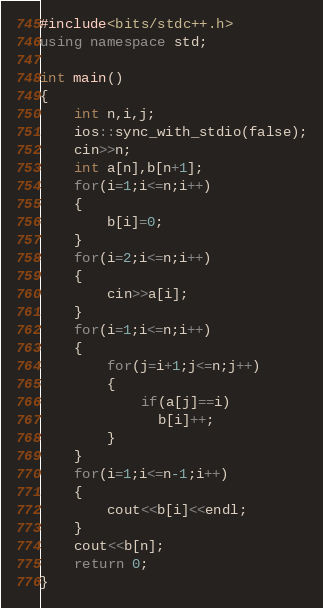<code> <loc_0><loc_0><loc_500><loc_500><_C++_>#include<bits/stdc++.h>
using namespace std;

int main()
{
	int n,i,j;
	ios::sync_with_stdio(false);
	cin>>n;
	int a[n],b[n+1];
	for(i=1;i<=n;i++)
	{
		b[i]=0;
	}
	for(i=2;i<=n;i++)
	{
		cin>>a[i];
	}
	for(i=1;i<=n;i++)
	{
		for(j=i+1;j<=n;j++)
		{
			if(a[j]==i)
			  b[i]++;
		}
	}
	for(i=1;i<=n-1;i++)
	{
		cout<<b[i]<<endl;
	}
	cout<<b[n];
	return 0;
} </code> 